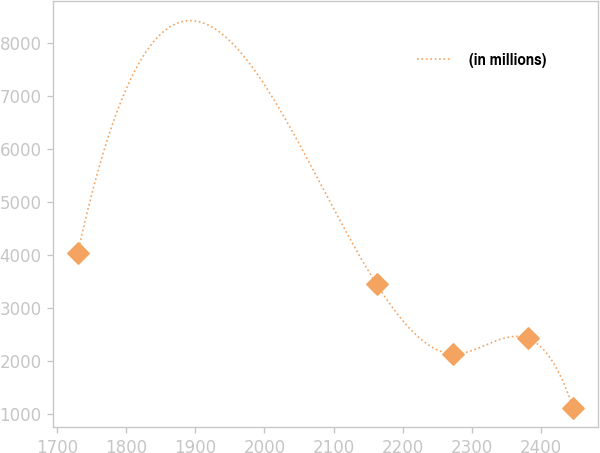Convert chart. <chart><loc_0><loc_0><loc_500><loc_500><line_chart><ecel><fcel>(in millions)<nl><fcel>1729.88<fcel>4043.18<nl><fcel>2162.57<fcel>3448.21<nl><fcel>2273.6<fcel>2138.16<nl><fcel>2381.21<fcel>2429.97<nl><fcel>2446.69<fcel>1125.07<nl></chart> 